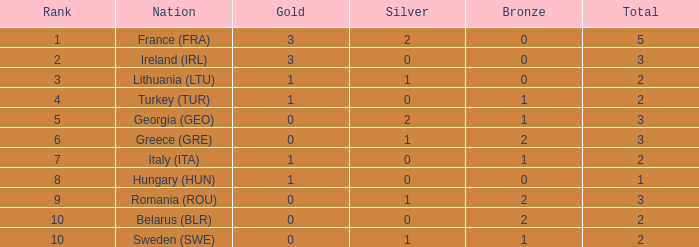What is the sum of sweden (swe) having fewer than 1 silver? None. 